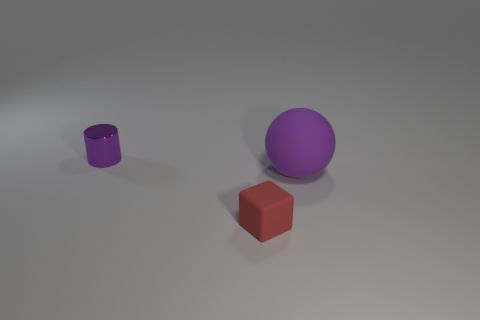Add 1 big blue metallic balls. How many objects exist? 4 Subtract all spheres. How many objects are left? 2 Add 1 small blocks. How many small blocks are left? 2 Add 1 big cyan metallic spheres. How many big cyan metallic spheres exist? 1 Subtract 0 cyan cylinders. How many objects are left? 3 Subtract all large metallic cylinders. Subtract all large rubber balls. How many objects are left? 2 